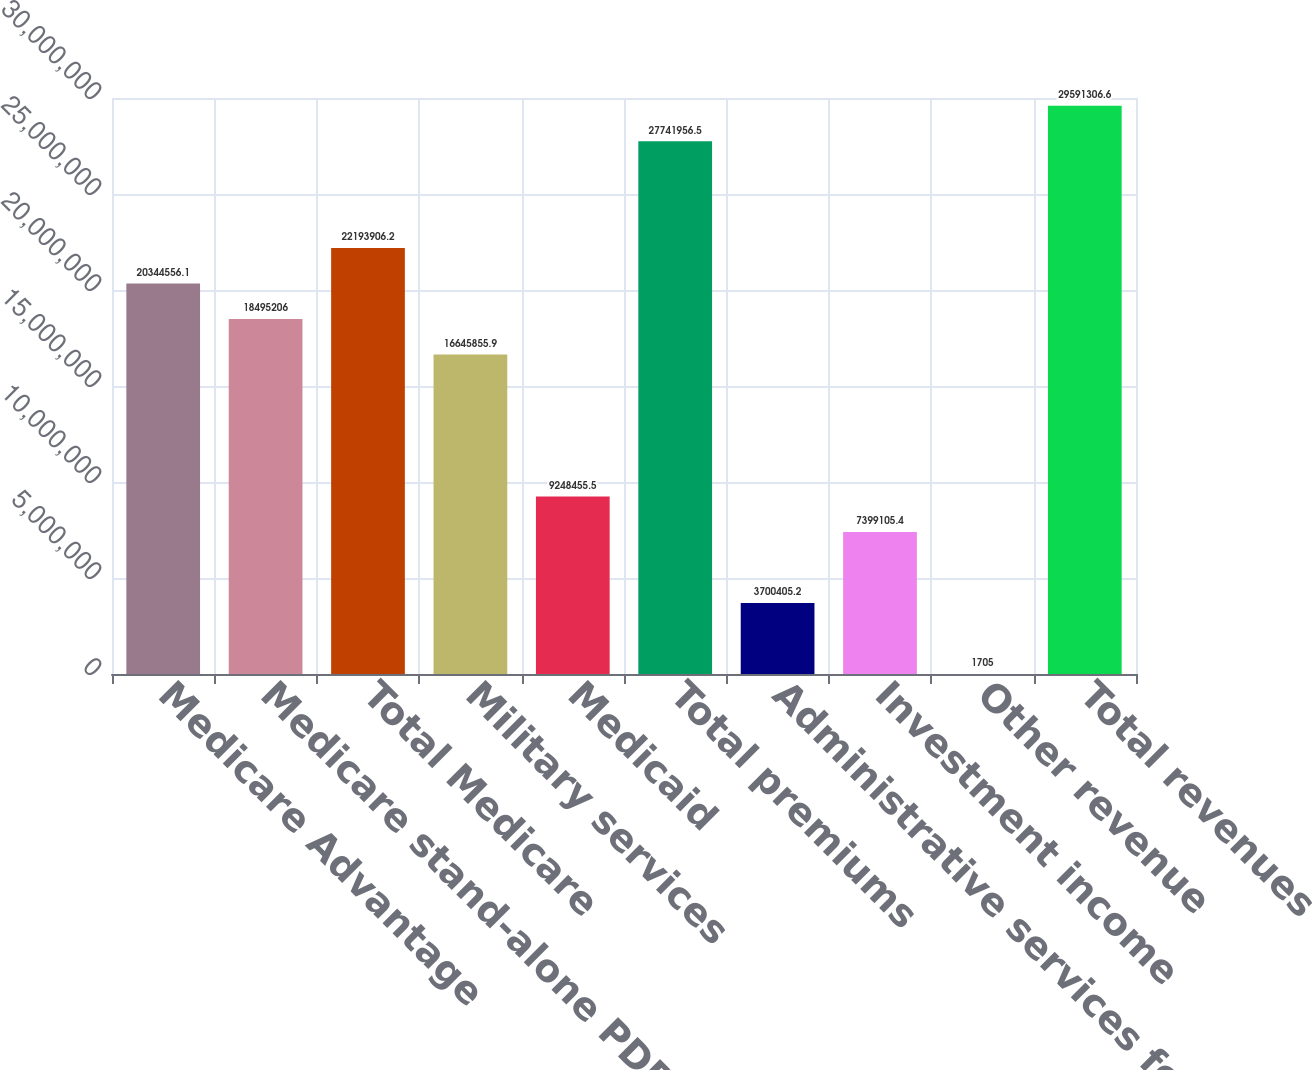Convert chart. <chart><loc_0><loc_0><loc_500><loc_500><bar_chart><fcel>Medicare Advantage<fcel>Medicare stand-alone PDP<fcel>Total Medicare<fcel>Military services<fcel>Medicaid<fcel>Total premiums<fcel>Administrative services fees<fcel>Investment income<fcel>Other revenue<fcel>Total revenues<nl><fcel>2.03446e+07<fcel>1.84952e+07<fcel>2.21939e+07<fcel>1.66459e+07<fcel>9.24846e+06<fcel>2.7742e+07<fcel>3.70041e+06<fcel>7.39911e+06<fcel>1705<fcel>2.95913e+07<nl></chart> 